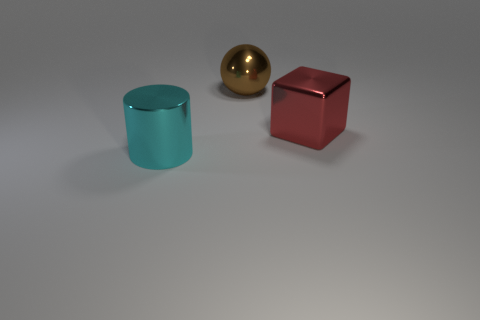How many other things are the same color as the big cylinder?
Keep it short and to the point. 0. Are there fewer shiny cylinders than large objects?
Your answer should be very brief. Yes. How many balls are matte things or red objects?
Your response must be concise. 0. There is a big thing that is right of the cyan cylinder and in front of the brown metallic thing; what shape is it?
Offer a very short reply. Cube. There is a thing that is to the left of the thing that is behind the big red shiny thing that is in front of the big sphere; what color is it?
Your answer should be compact. Cyan. Is the number of big cyan cylinders on the right side of the big red object less than the number of tiny cyan balls?
Your response must be concise. No. How many objects are either big shiny objects in front of the large red object or green cylinders?
Provide a succinct answer. 1. There is a object that is in front of the big metallic thing right of the large sphere; are there any shiny cylinders on the left side of it?
Offer a very short reply. No. Are there fewer cyan things that are to the right of the large metal cylinder than large cyan shiny cylinders left of the big red block?
Give a very brief answer. Yes. The large cylinder that is the same material as the large sphere is what color?
Your answer should be very brief. Cyan. 